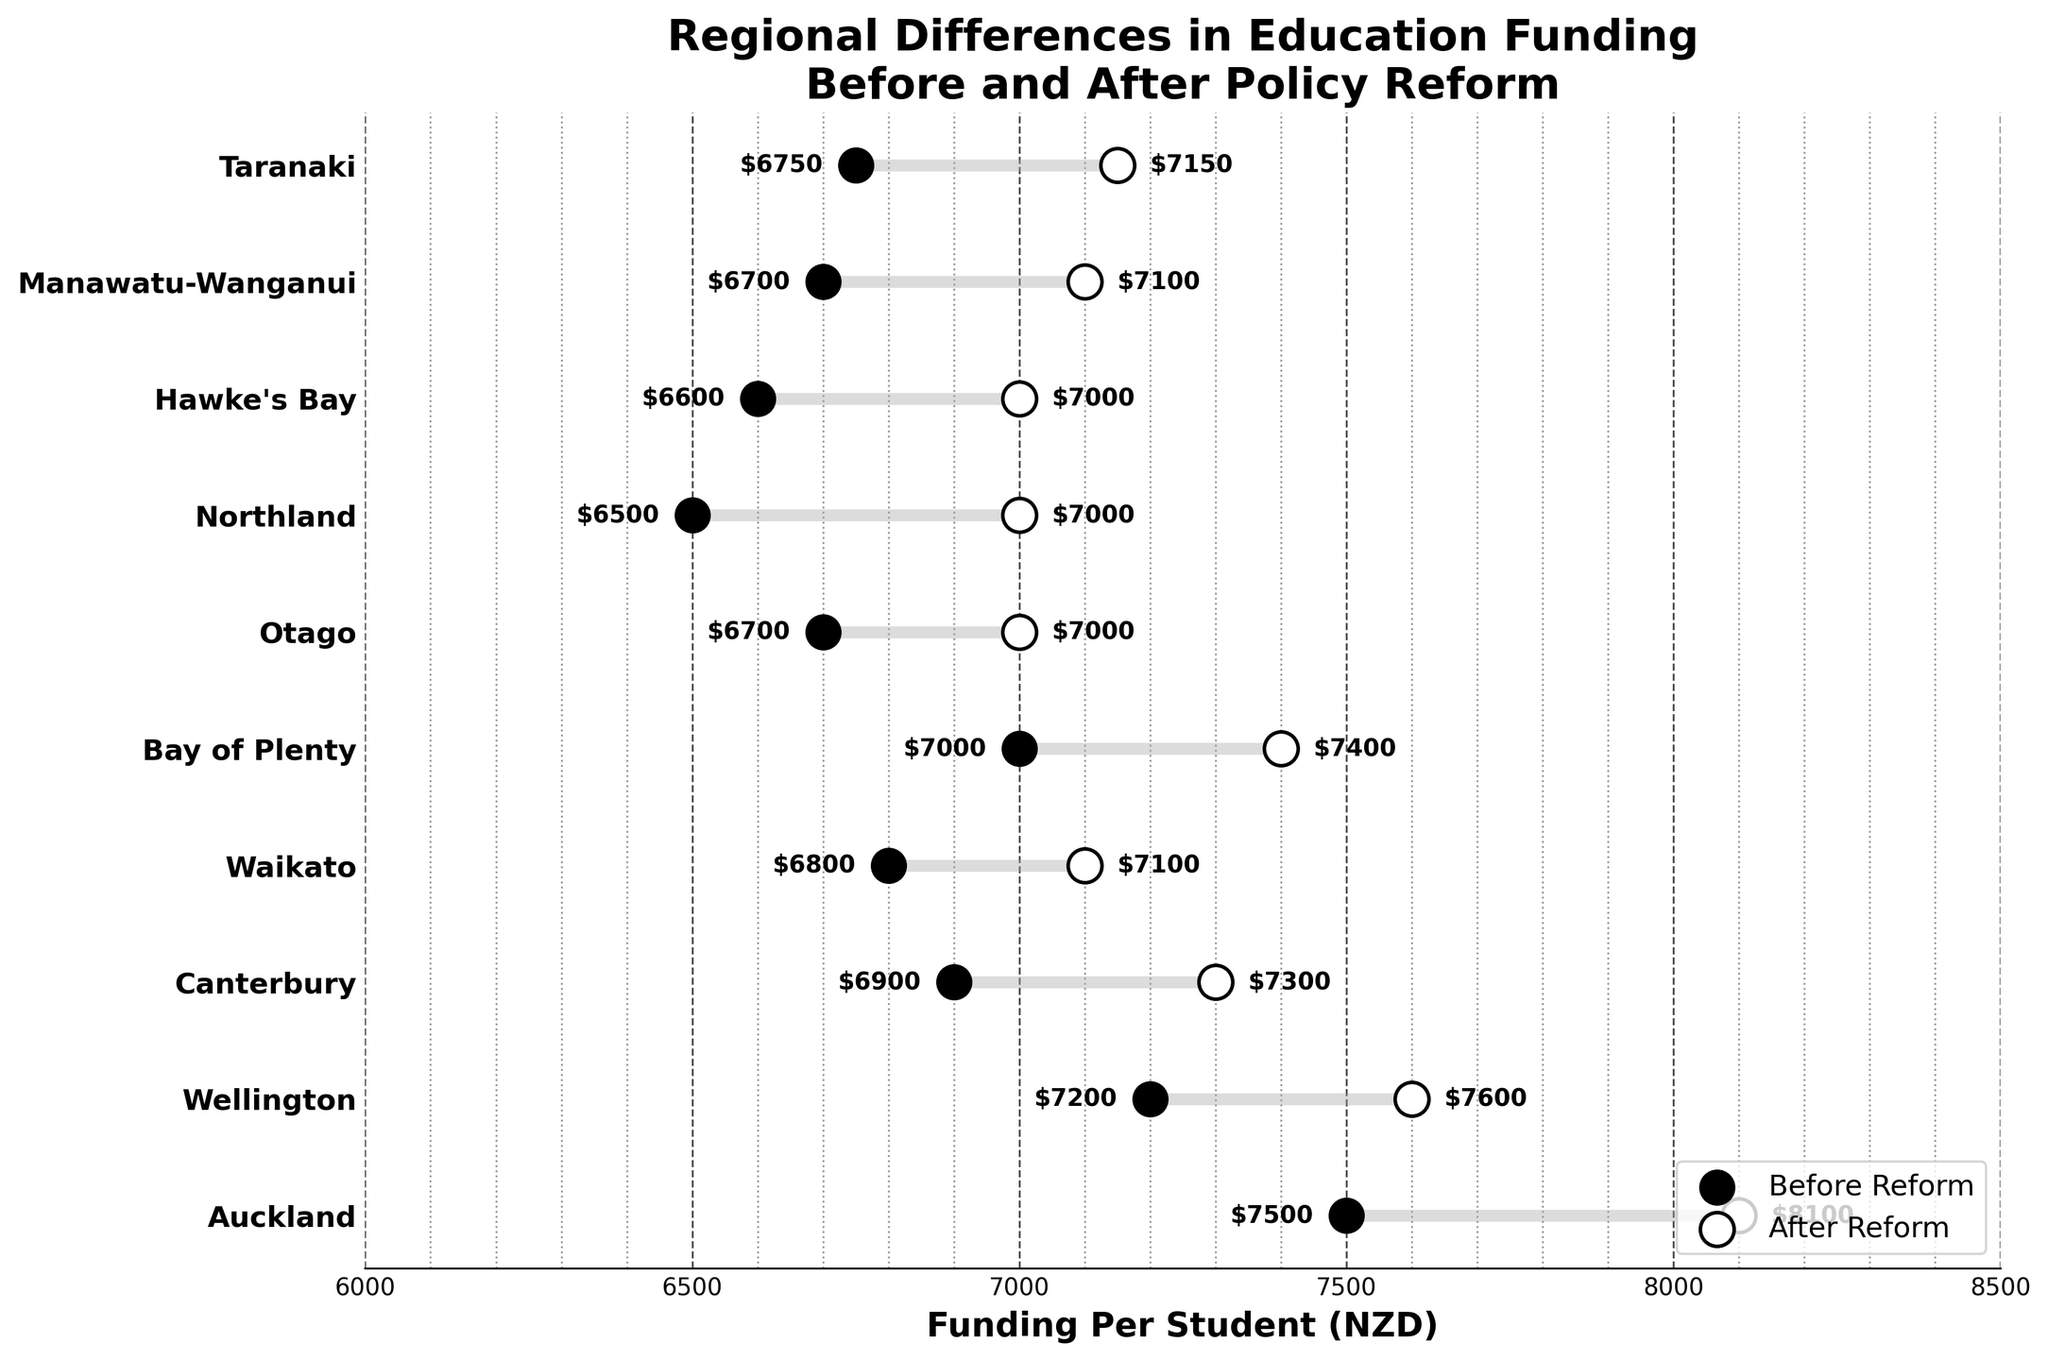Which region had the highest increase in funding per student after the reform? To find the region with the highest increase, subtract the funding before reform from the funding after reform for all regions. Auckland had the highest increase from $7500 to $8100, which is an increase of $600.
Answer: Auckland What is the average funding per student after the reform across all regions? Add the funding per student after reform for all regions and divide by the number of regions. The total is $8100 + $7600 + $7300 + $7100 + $7400 + $7000 + $7000 + $7000 + $7100 + $7150 = $72650. There are 10 regions, so the average is $72650 / 10 = $7265.
Answer: $7265 Which region had the smallest difference in funding per student before and after the reform? Subtract the funding before reform from the funding after reform for all regions. Wellington had the smallest difference, with funding increasing from $7200 to $7600, a difference of $400.
Answer: Wellington What was the total increase in funding for students in Bay of Plenty and Otago regions? Calculate the difference before and after the reform for both regions and sum them. Bay of Plenty increased from $7000 to $7400 ($400), and Otago from $6700 to $7000 ($300). So, the total increase is $400 + $300 = $700.
Answer: $700 What is the range of funding per student after the reform across the regions? Subtract the smallest value from the largest value after the reform. The largest funding after the reform is in Auckland ($8100) and the smallest in Otago, Northland, and Hawke's Bay ($7000). The range is $8100 - $7000 = $1100.
Answer: $1100 Which regions had a funding per student increase of $500 after the reform? Subtract the funding before reform from the funding after reform for all regions. Canterbury, Waikato, Northland, and Hawke's Bay all showed an increase of $500.
Answer: Canterbury, Waikato, Northland, Hawke's Bay What was the median funding per student before the reform across all regions? To find the median, list the funding before reform for all regions in ascending order and find the middle value. The order is $6500, $6600, $6700, $6700, $6750, $6800, $6900, $7000, $7200, $7500. The median of this sorted list (middle value) is the average of $6750 and $6800, which is ($6750 + $6800) / 2 = $6775.
Answer: $6775 Which region had the second highest funding per student before the reform? List the funding amounts before the reform in descending order and identify the second highest. In descending order: Auckland ($7500), Wellington ($7200), Canterbury ($6900), etc. The second highest is Wellington with $7200.
Answer: Wellington 